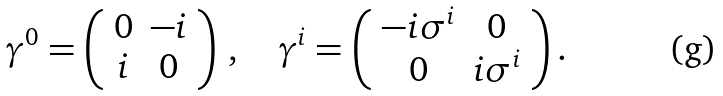Convert formula to latex. <formula><loc_0><loc_0><loc_500><loc_500>\gamma ^ { 0 } = \left ( \begin{array} { c c } 0 & - i \\ i & 0 \end{array} \right ) \, , \quad \gamma ^ { i } = \left ( \begin{array} { c c } - i \sigma ^ { i } & 0 \\ 0 & i \sigma ^ { i } \end{array} \right ) .</formula> 